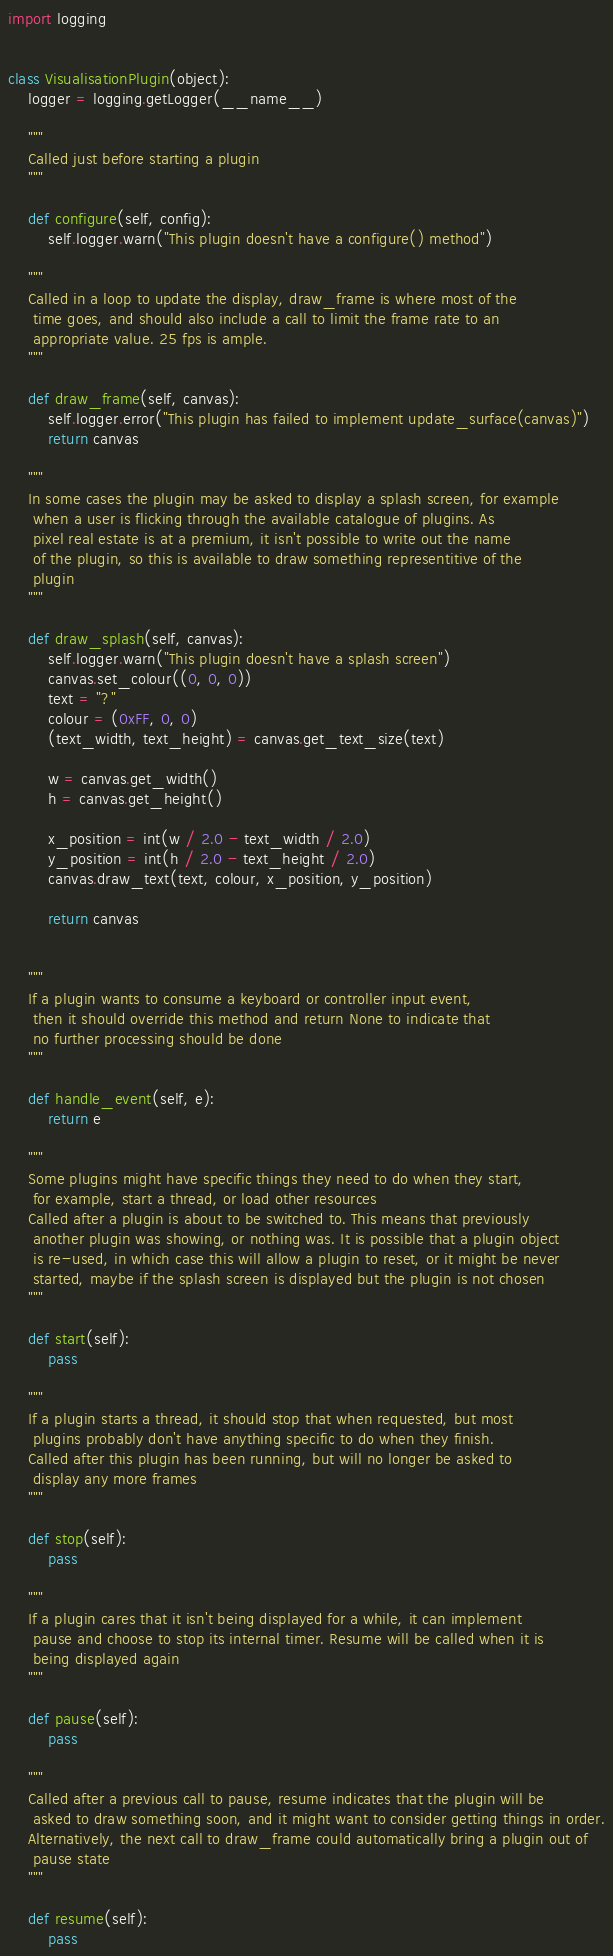Convert code to text. <code><loc_0><loc_0><loc_500><loc_500><_Python_>import logging


class VisualisationPlugin(object):
    logger = logging.getLogger(__name__)

    """
    Called just before starting a plugin
    """

    def configure(self, config):
        self.logger.warn("This plugin doesn't have a configure() method")

    """
    Called in a loop to update the display, draw_frame is where most of the
     time goes, and should also include a call to limit the frame rate to an
     appropriate value. 25 fps is ample.
    """

    def draw_frame(self, canvas):
        self.logger.error("This plugin has failed to implement update_surface(canvas)")
        return canvas

    """
    In some cases the plugin may be asked to display a splash screen, for example
     when a user is flicking through the available catalogue of plugins. As
     pixel real estate is at a premium, it isn't possible to write out the name
     of the plugin, so this is available to draw something representitive of the
     plugin
    """

    def draw_splash(self, canvas):
        self.logger.warn("This plugin doesn't have a splash screen")
        canvas.set_colour((0, 0, 0))
        text = "?"
        colour = (0xFF, 0, 0)
        (text_width, text_height) = canvas.get_text_size(text)

        w = canvas.get_width()
        h = canvas.get_height()

        x_position = int(w / 2.0 - text_width / 2.0)
        y_position = int(h / 2.0 - text_height / 2.0)
        canvas.draw_text(text, colour, x_position, y_position)

        return canvas


    """
    If a plugin wants to consume a keyboard or controller input event,
     then it should override this method and return None to indicate that
     no further processing should be done
    """

    def handle_event(self, e):
        return e

    """
    Some plugins might have specific things they need to do when they start,
     for example, start a thread, or load other resources
    Called after a plugin is about to be switched to. This means that previously
     another plugin was showing, or nothing was. It is possible that a plugin object
     is re-used, in which case this will allow a plugin to reset, or it might be never
     started, maybe if the splash screen is displayed but the plugin is not chosen
    """

    def start(self):
        pass

    """
    If a plugin starts a thread, it should stop that when requested, but most
     plugins probably don't have anything specific to do when they finish.
    Called after this plugin has been running, but will no longer be asked to
     display any more frames
    """

    def stop(self):
        pass

    """
    If a plugin cares that it isn't being displayed for a while, it can implement
     pause and choose to stop its internal timer. Resume will be called when it is
     being displayed again
    """

    def pause(self):
        pass

    """
    Called after a previous call to pause, resume indicates that the plugin will be
     asked to draw something soon, and it might want to consider getting things in order.
    Alternatively, the next call to draw_frame could automatically bring a plugin out of
     pause state
    """

    def resume(self):
        pass
</code> 